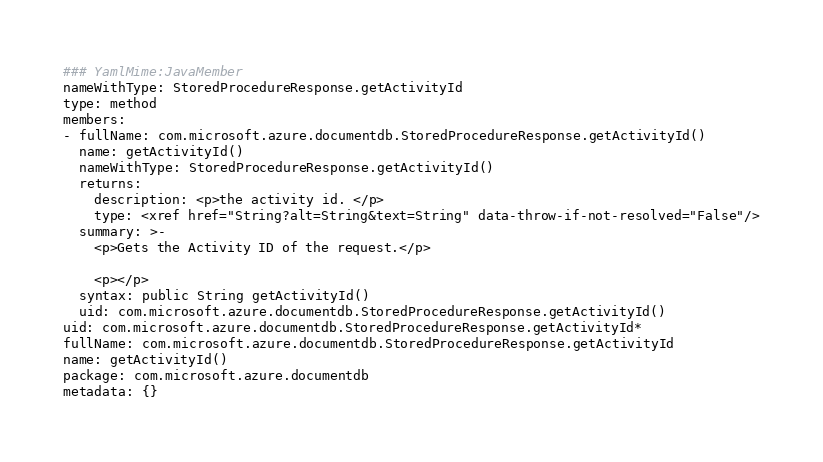<code> <loc_0><loc_0><loc_500><loc_500><_YAML_>### YamlMime:JavaMember
nameWithType: StoredProcedureResponse.getActivityId
type: method
members:
- fullName: com.microsoft.azure.documentdb.StoredProcedureResponse.getActivityId()
  name: getActivityId()
  nameWithType: StoredProcedureResponse.getActivityId()
  returns:
    description: <p>the activity id. </p>
    type: <xref href="String?alt=String&text=String" data-throw-if-not-resolved="False"/>
  summary: >-
    <p>Gets the Activity ID of the request.</p>

    <p></p>
  syntax: public String getActivityId()
  uid: com.microsoft.azure.documentdb.StoredProcedureResponse.getActivityId()
uid: com.microsoft.azure.documentdb.StoredProcedureResponse.getActivityId*
fullName: com.microsoft.azure.documentdb.StoredProcedureResponse.getActivityId
name: getActivityId()
package: com.microsoft.azure.documentdb
metadata: {}
</code> 